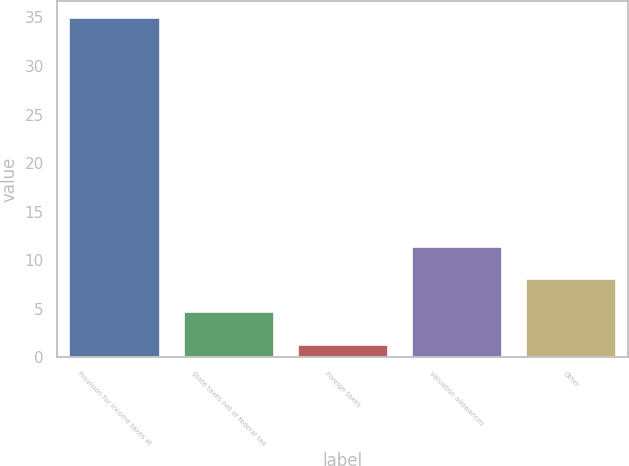Convert chart to OTSL. <chart><loc_0><loc_0><loc_500><loc_500><bar_chart><fcel>Provision for income taxes at<fcel>State taxes net of federal tax<fcel>Foreign taxes<fcel>Valuation allowances<fcel>Other<nl><fcel>35<fcel>4.76<fcel>1.4<fcel>11.48<fcel>8.12<nl></chart> 